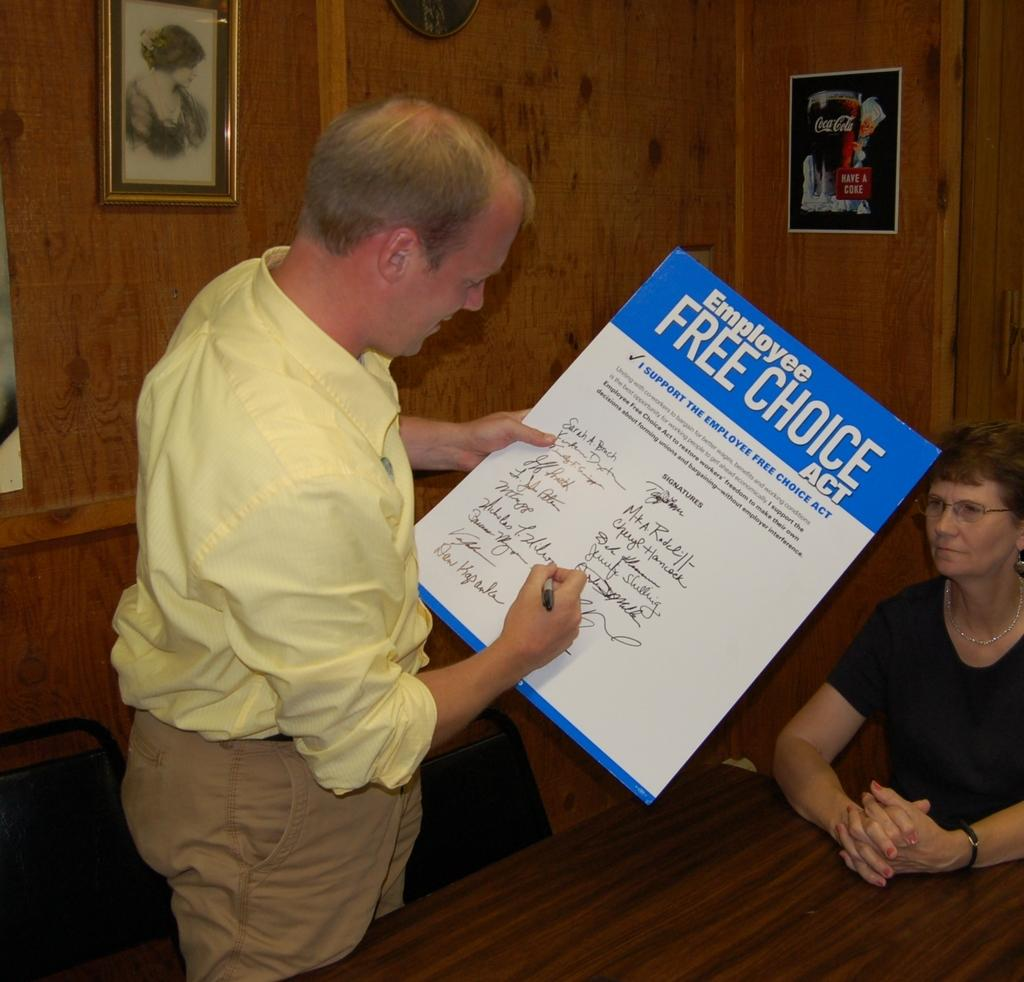What is the man in the image holding? The man is holding a poster and a pen in the image. Can you describe the lady's position in the image? The lady is sitting on the right side of the image. What is located at the bottom of the image? There is a table at the bottom of the image. What can be seen in the background of the image? There are frames in the background of the image. What type of silk is being used to cover the lady's face in the image? There is no silk or any covering on the lady's face in the image; she is simply sitting. What is the lady feeling shame about in the image? There is no indication of shame or any emotion in the image; the lady is just sitting. 